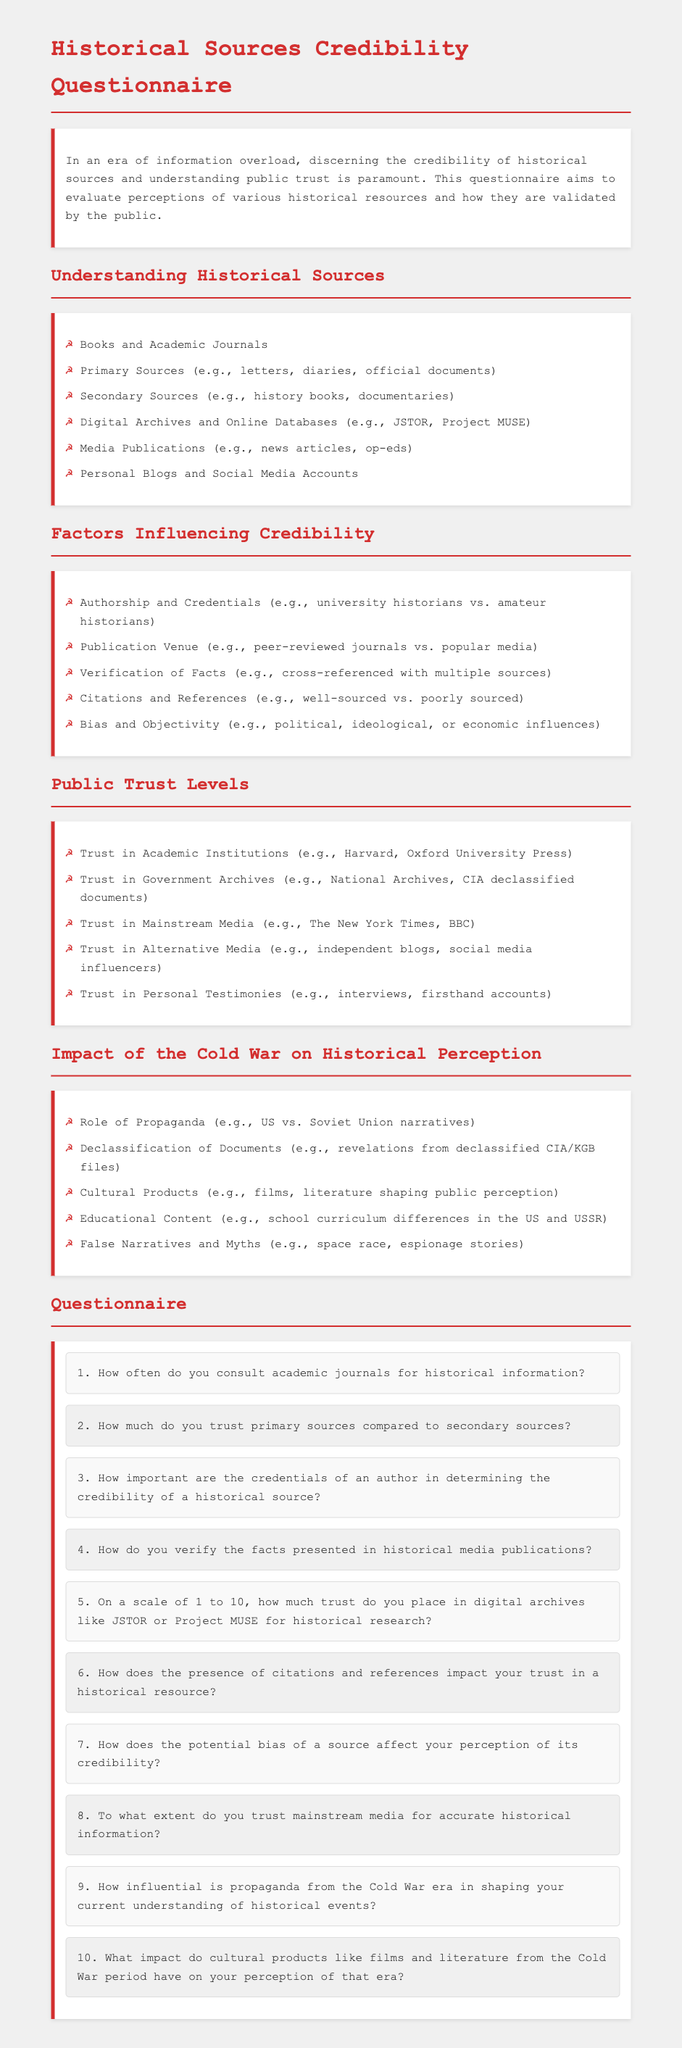What types of historical sources are listed? The document provides a list of historical sources, which includes books, primary sources, secondary sources, digital archives, media publications, and blogs.
Answer: Books and Academic Journals, Primary Sources, Secondary Sources, Digital Archives and Online Databases, Media Publications, Personal Blogs and Social Media Accounts What factors influence the credibility of historical sources? The document outlines several factors that affect how credible a historical source is perceived to be, such as authorship, verification of facts, citations, and bias.
Answer: Authorship and Credentials, Publication Venue, Verification of Facts, Citations and References, Bias and Objectivity How much trust do people place in mainstream media for accurate historical information? The document includes a question in the questionnaire asking participants about their trust levels regarding mainstream media.
Answer: To what extent do you trust mainstream media for accurate historical information? What is the focus of the questionnaire? The overall aim of the questionnaire is stated in the introductory paragraph, focusing on evaluating perceptions of historical resources and public trust in them.
Answer: Evaluate perceptions of various historical resources and how they are validated by the public Which Cold War-related impact is mentioned in the questionnaire? The document lists several impacts of the Cold War, including propaganda and declassification of documents, that can influence historical perceptions.
Answer: Role of Propaganda, Declassification of Documents, Cultural Products, Educational Content, False Narratives and Myths On a scale of what numbers is trust assessed in digital archives? The questionnaire specifically uses a scale of 1 to 10 to assess trust levels in digital archives for historical research.
Answer: 1 to 10 